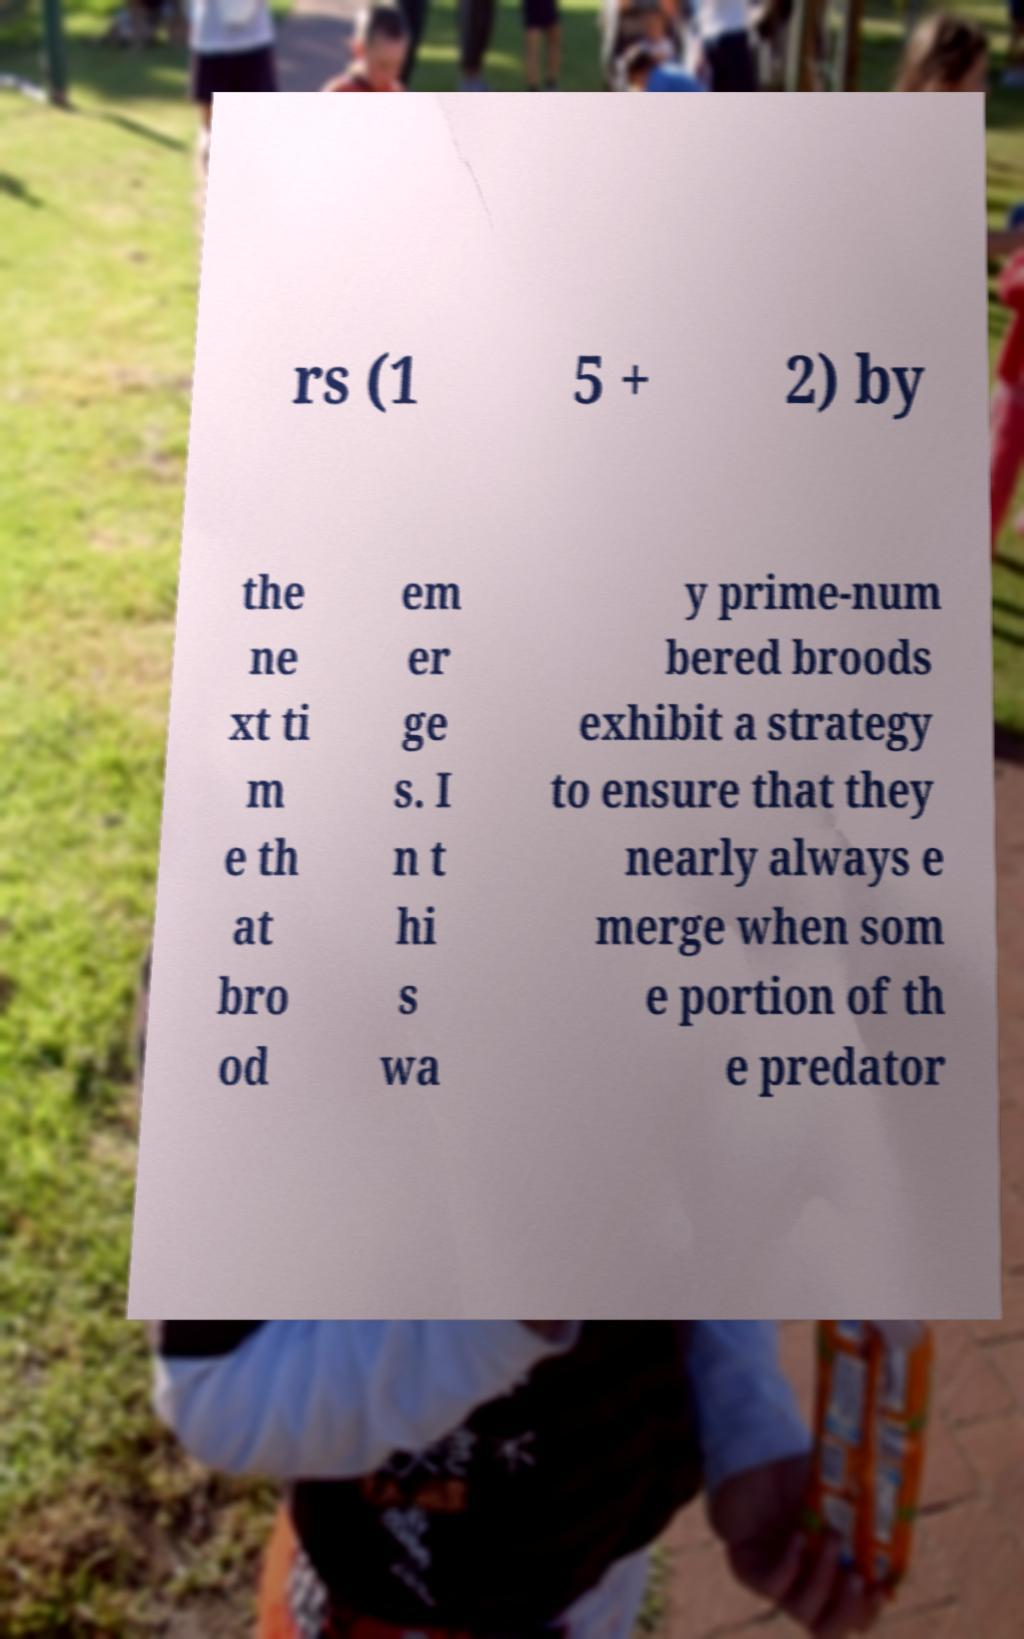Could you extract and type out the text from this image? rs (1 5 + 2) by the ne xt ti m e th at bro od em er ge s. I n t hi s wa y prime-num bered broods exhibit a strategy to ensure that they nearly always e merge when som e portion of th e predator 